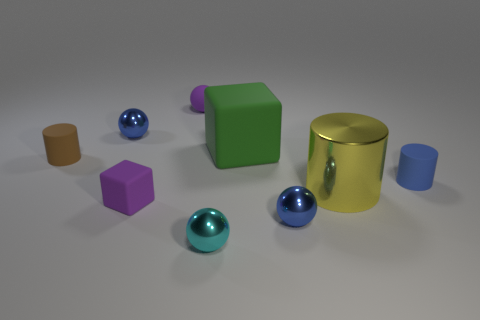Subtract 1 balls. How many balls are left? 3 Add 1 shiny cylinders. How many objects exist? 10 Subtract all cylinders. How many objects are left? 6 Add 6 blocks. How many blocks are left? 8 Add 7 brown matte objects. How many brown matte objects exist? 8 Subtract 0 gray cylinders. How many objects are left? 9 Subtract all cyan shiny blocks. Subtract all big metal cylinders. How many objects are left? 8 